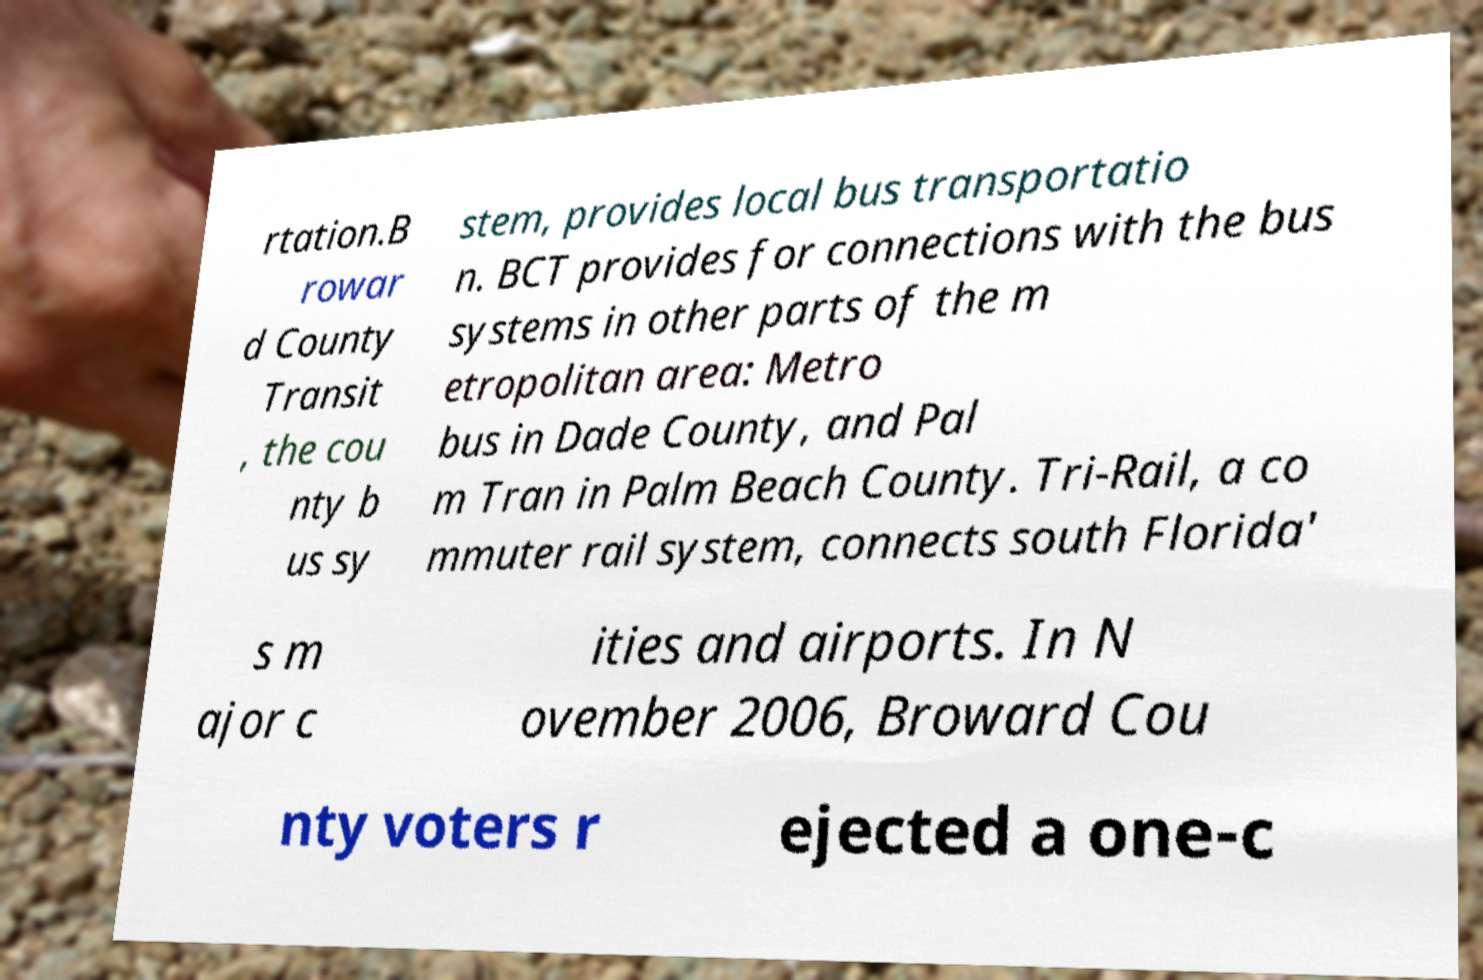For documentation purposes, I need the text within this image transcribed. Could you provide that? rtation.B rowar d County Transit , the cou nty b us sy stem, provides local bus transportatio n. BCT provides for connections with the bus systems in other parts of the m etropolitan area: Metro bus in Dade County, and Pal m Tran in Palm Beach County. Tri-Rail, a co mmuter rail system, connects south Florida' s m ajor c ities and airports. In N ovember 2006, Broward Cou nty voters r ejected a one-c 